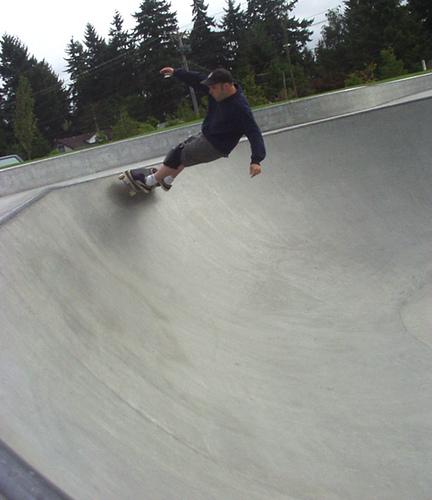Is there graffiti on the ramp?
Quick response, please. No. Is the man wearing a helmet?
Quick response, please. No. Is the man losing his balance?
Keep it brief. No. What color is the ramp?
Quick response, please. Gray. 